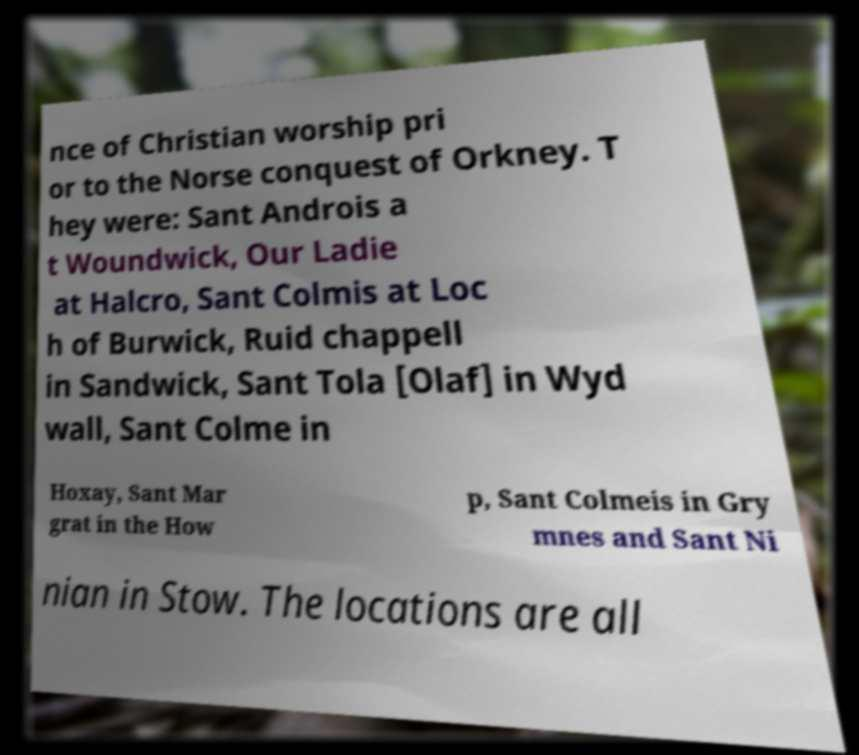Please read and relay the text visible in this image. What does it say? nce of Christian worship pri or to the Norse conquest of Orkney. T hey were: Sant Androis a t Woundwick, Our Ladie at Halcro, Sant Colmis at Loc h of Burwick, Ruid chappell in Sandwick, Sant Tola [Olaf] in Wyd wall, Sant Colme in Hoxay, Sant Mar grat in the How p, Sant Colmeis in Gry mnes and Sant Ni nian in Stow. The locations are all 